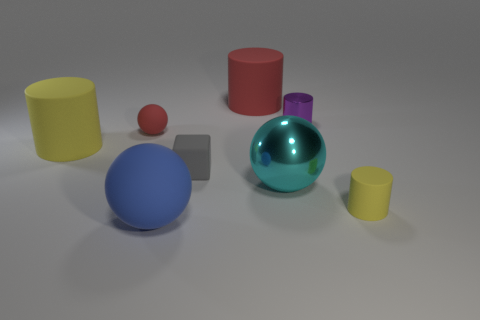Can you tell me about the materials the objects in the image seem to be made of? The objects in the image appear to have been rendered with different material properties. The large blue sphere, the red cylinder, and the smaller yellow cylinder seem to have a matte finish, indicating a non-reflective surface material. Conversely, the cyan object and the small purple object have a shiny appearance, suggesting they might represent materials with a glossy or metallic finish. The gray cube looks somewhat matte as well, while the large greenish-blue sphere presents a transparent, glass-like material. 